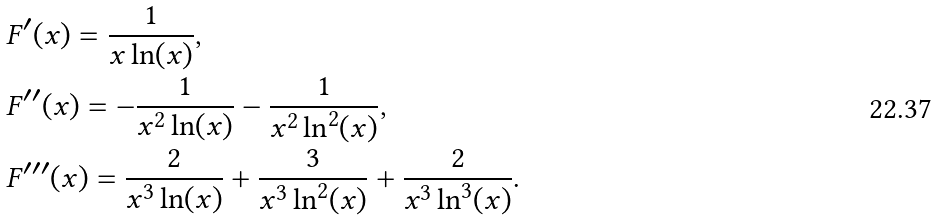Convert formula to latex. <formula><loc_0><loc_0><loc_500><loc_500>& F ^ { \prime } ( x ) = \frac { 1 } { x \ln ( x ) } , \\ & F ^ { \prime \prime } ( x ) = - \frac { 1 } { x ^ { 2 } \ln ( x ) } - \frac { 1 } { x ^ { 2 } \ln ^ { 2 } ( x ) } , \\ & F ^ { \prime \prime \prime } ( x ) = \frac { 2 } { x ^ { 3 } \ln ( x ) } + \frac { 3 } { x ^ { 3 } \ln ^ { 2 } ( x ) } + \frac { 2 } { x ^ { 3 } \ln ^ { 3 } ( x ) } .</formula> 